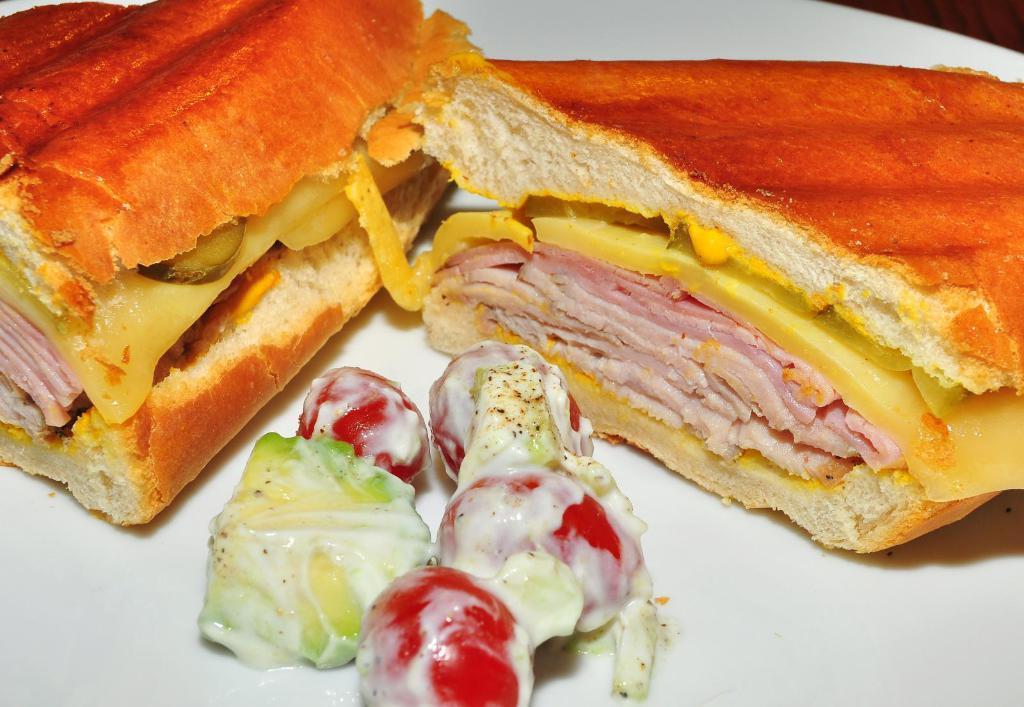Describe this image in one or two sentences. It is a zoomed in picture of a plate of food items on the wooden surface. 